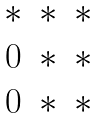<formula> <loc_0><loc_0><loc_500><loc_500>\begin{matrix} * & * & * \\ 0 & * & * \\ 0 & * & * \end{matrix}</formula> 